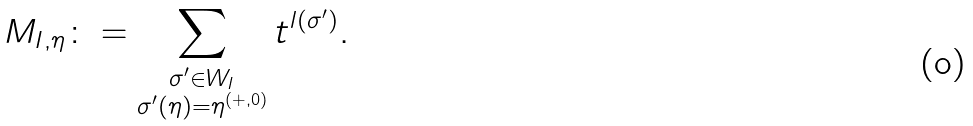Convert formula to latex. <formula><loc_0><loc_0><loc_500><loc_500>M _ { I , \eta } \colon = \sum _ { \substack { \sigma ^ { \prime } \in W _ { I } \\ \sigma ^ { \prime } \left ( \eta \right ) = \eta ^ { \left ( + , 0 \right ) } } } t ^ { l \left ( \sigma ^ { \prime } \right ) } .</formula> 